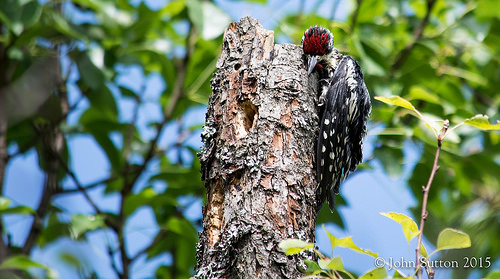<image>
Is there a wood on the leaves? No. The wood is not positioned on the leaves. They may be near each other, but the wood is not supported by or resting on top of the leaves. 